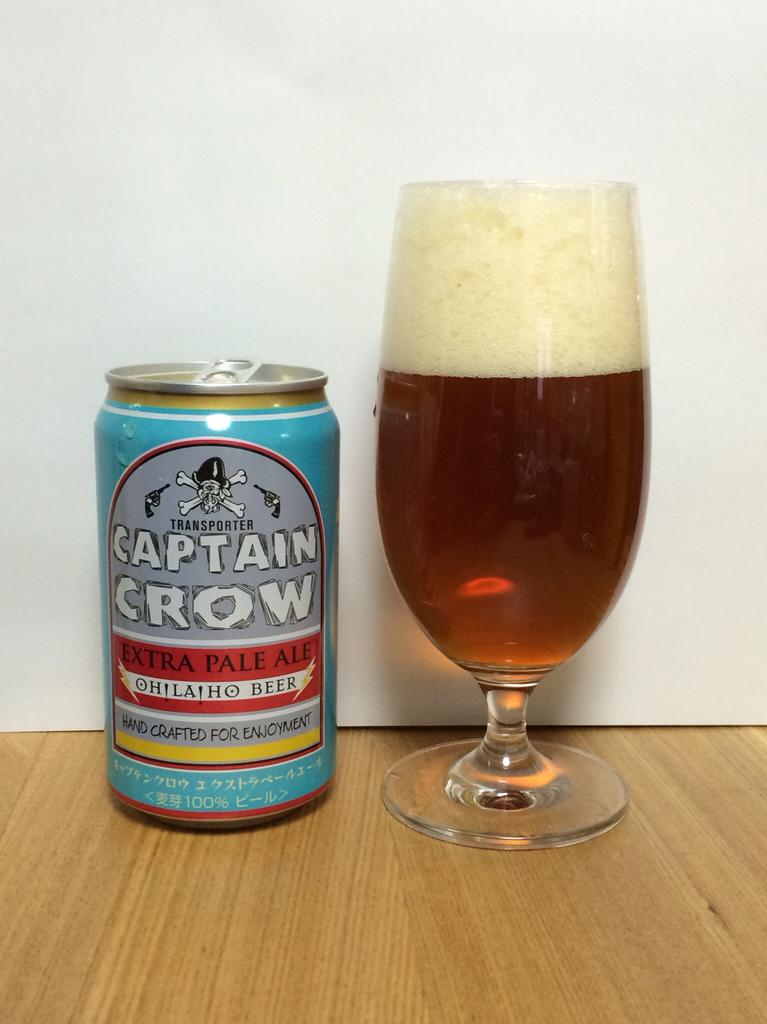<image>
Summarize the visual content of the image. A can of Captain Crow Pale Ale next to a glass of beer. 